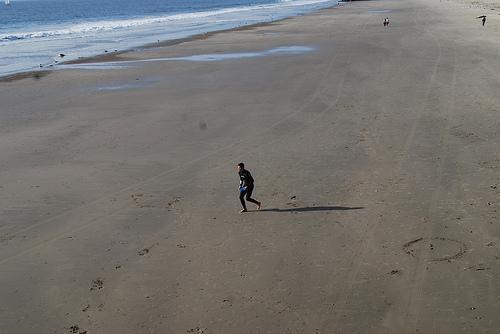How many people are visible on the beach?
Give a very brief answer. 3. 